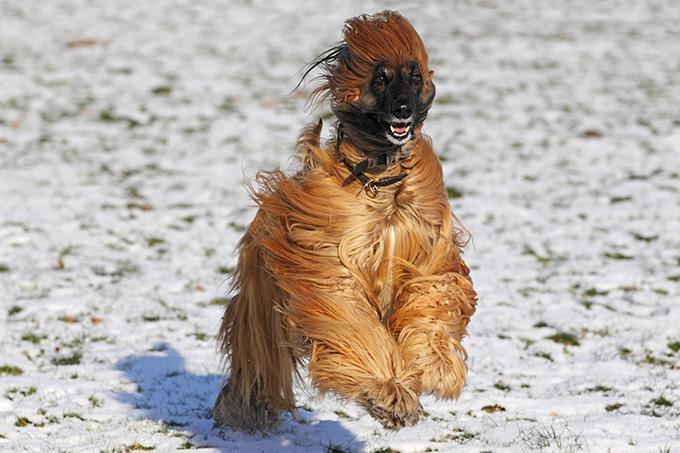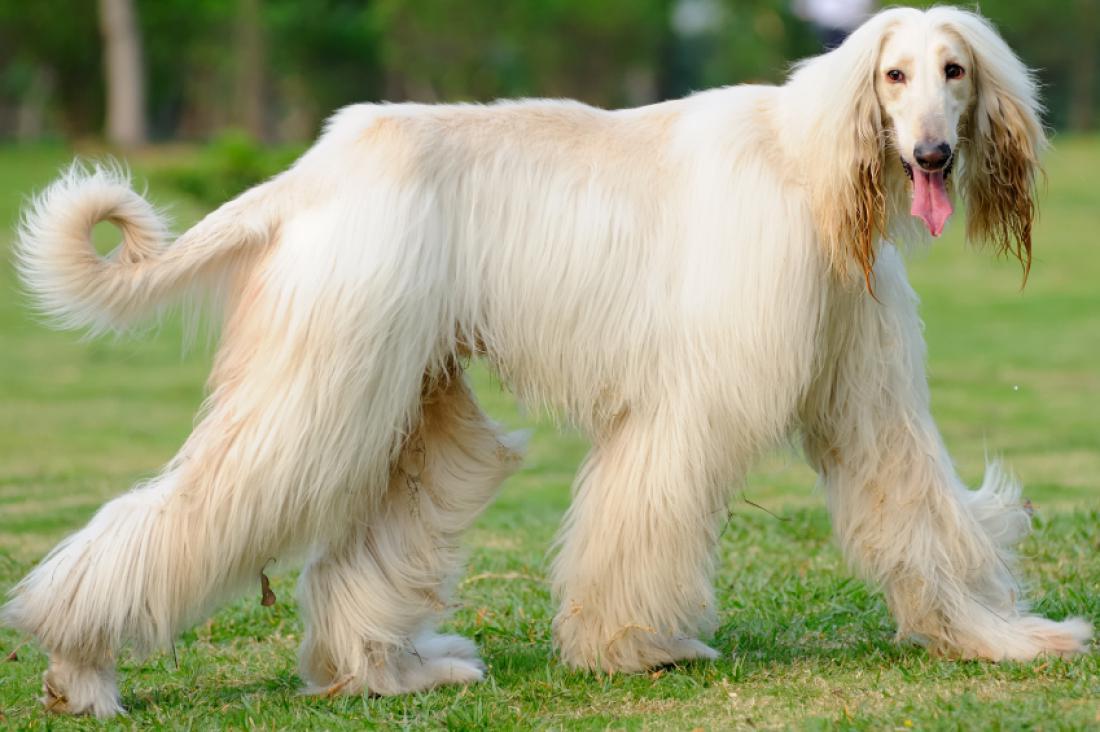The first image is the image on the left, the second image is the image on the right. For the images displayed, is the sentence "The dog in the left image is standing on snow-covered ground." factually correct? Answer yes or no. Yes. The first image is the image on the left, the second image is the image on the right. Given the left and right images, does the statement "The right image has a dog standing on a grassy surface" hold true? Answer yes or no. Yes. 